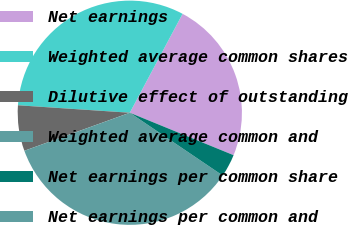Convert chart. <chart><loc_0><loc_0><loc_500><loc_500><pie_chart><fcel>Net earnings<fcel>Weighted average common shares<fcel>Dilutive effect of outstanding<fcel>Weighted average common and<fcel>Net earnings per common share<fcel>Net earnings per common and<nl><fcel>23.38%<fcel>31.74%<fcel>6.57%<fcel>35.03%<fcel>3.28%<fcel>0.0%<nl></chart> 